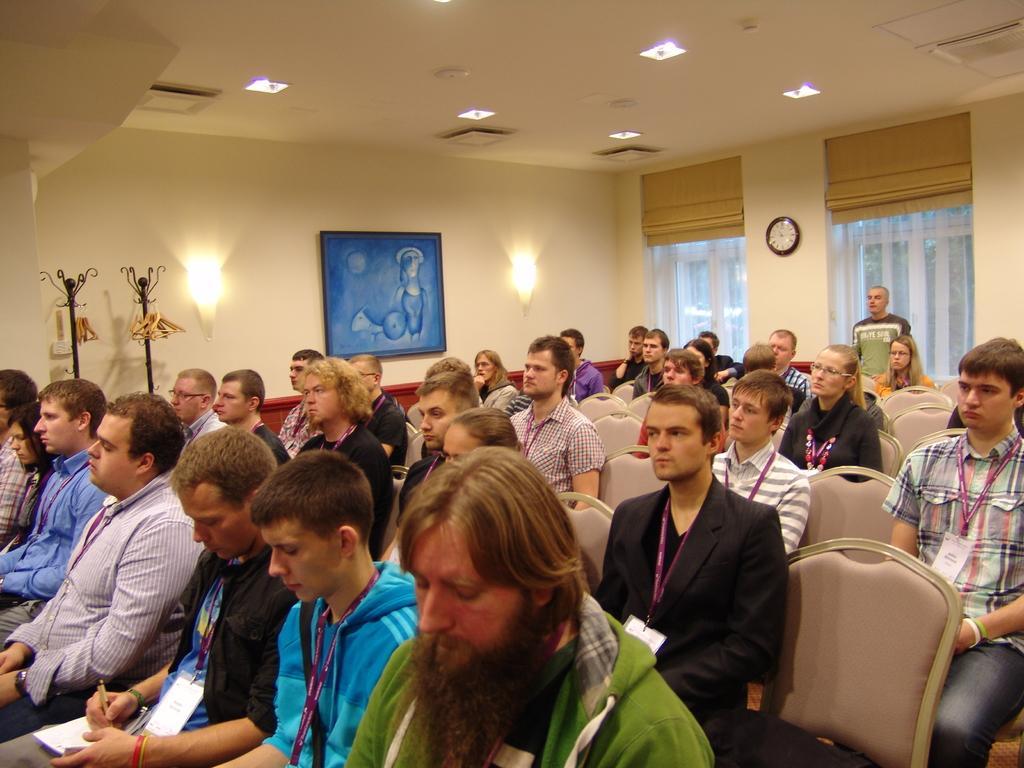Describe this image in one or two sentences. In this image there are windows, clock, lights, hangers, rods, picture, people, chairs and objects. Among them one person is standing in-front of the window. Lights, picture and clock are on the wall. Another person is holding a pen and a book.   